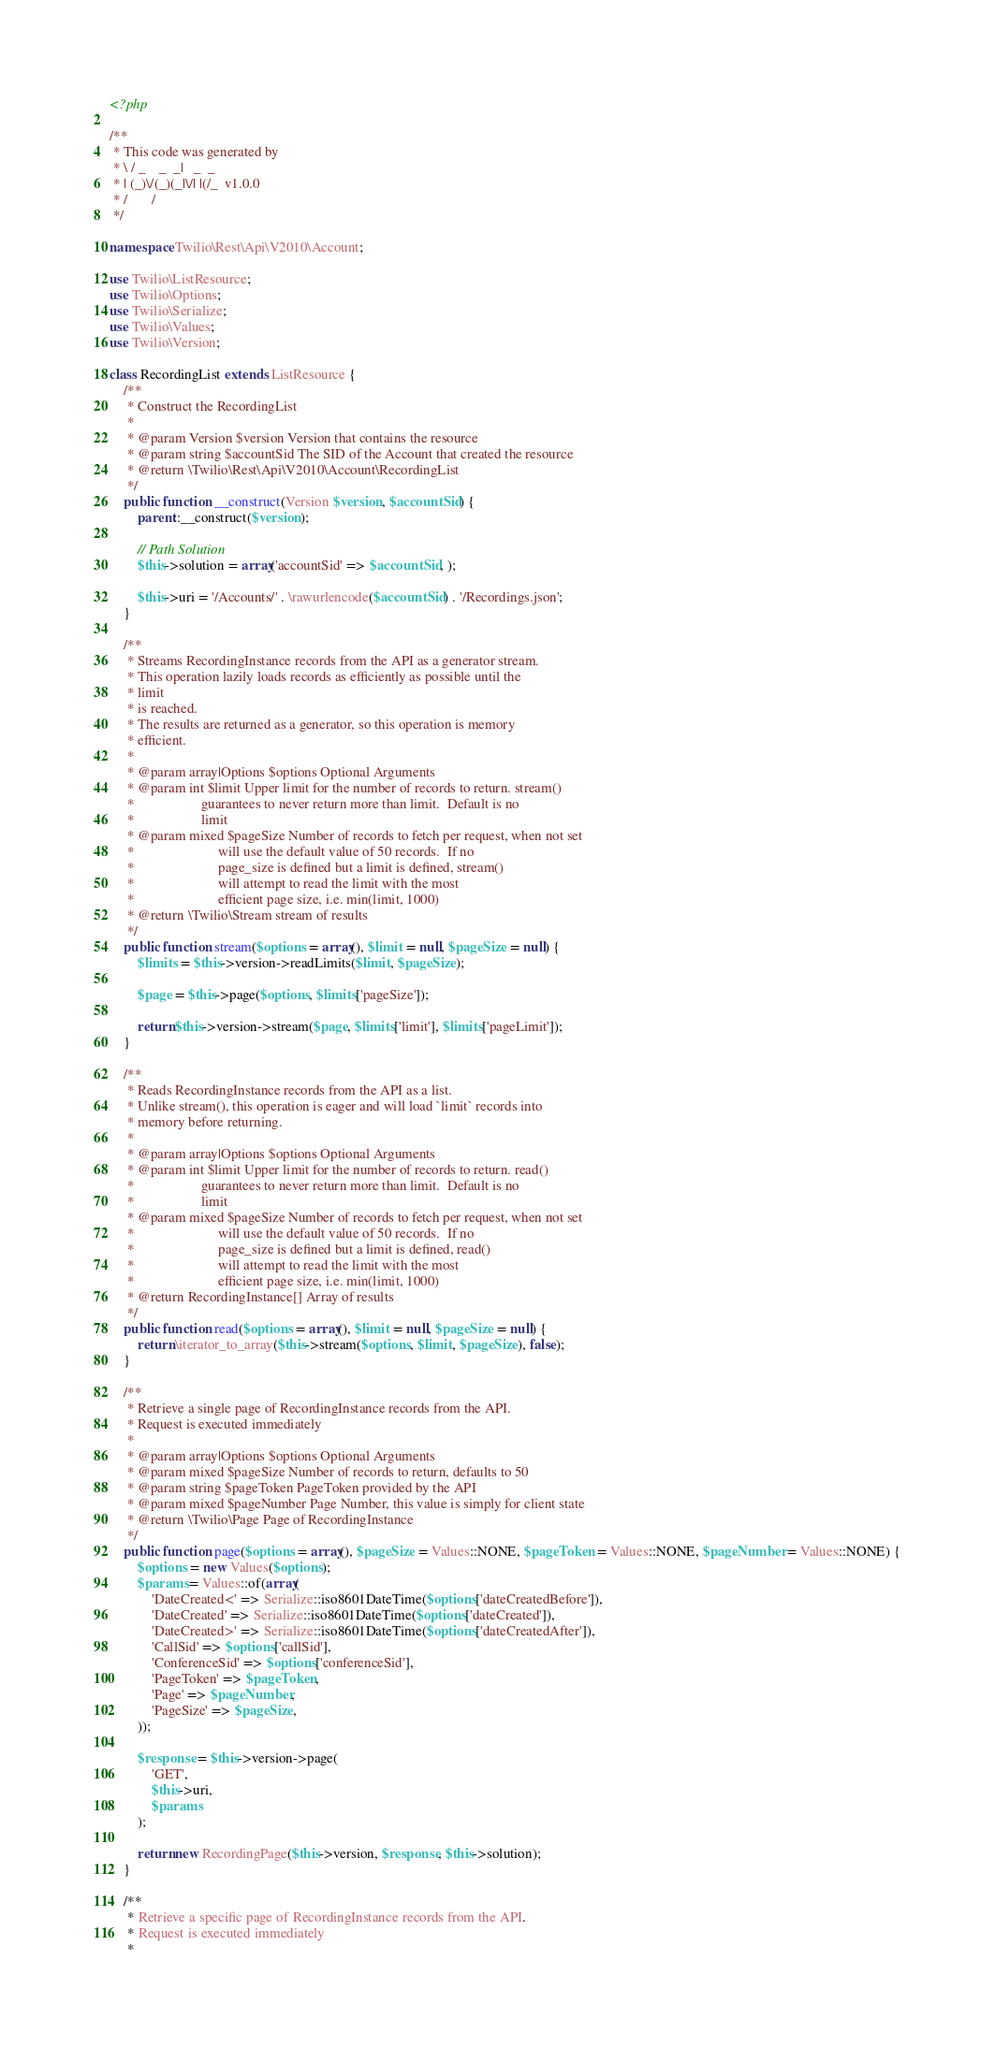<code> <loc_0><loc_0><loc_500><loc_500><_PHP_><?php

/**
 * This code was generated by
 * \ / _    _  _|   _  _
 * | (_)\/(_)(_|\/| |(/_  v1.0.0
 * /       /
 */

namespace Twilio\Rest\Api\V2010\Account;

use Twilio\ListResource;
use Twilio\Options;
use Twilio\Serialize;
use Twilio\Values;
use Twilio\Version;

class RecordingList extends ListResource {
    /**
     * Construct the RecordingList
     *
     * @param Version $version Version that contains the resource
     * @param string $accountSid The SID of the Account that created the resource
     * @return \Twilio\Rest\Api\V2010\Account\RecordingList
     */
    public function __construct(Version $version, $accountSid) {
        parent::__construct($version);

        // Path Solution
        $this->solution = array('accountSid' => $accountSid, );

        $this->uri = '/Accounts/' . \rawurlencode($accountSid) . '/Recordings.json';
    }

    /**
     * Streams RecordingInstance records from the API as a generator stream.
     * This operation lazily loads records as efficiently as possible until the
     * limit
     * is reached.
     * The results are returned as a generator, so this operation is memory
     * efficient.
     *
     * @param array|Options $options Optional Arguments
     * @param int $limit Upper limit for the number of records to return. stream()
     *                   guarantees to never return more than limit.  Default is no
     *                   limit
     * @param mixed $pageSize Number of records to fetch per request, when not set
     *                        will use the default value of 50 records.  If no
     *                        page_size is defined but a limit is defined, stream()
     *                        will attempt to read the limit with the most
     *                        efficient page size, i.e. min(limit, 1000)
     * @return \Twilio\Stream stream of results
     */
    public function stream($options = array(), $limit = null, $pageSize = null) {
        $limits = $this->version->readLimits($limit, $pageSize);

        $page = $this->page($options, $limits['pageSize']);

        return $this->version->stream($page, $limits['limit'], $limits['pageLimit']);
    }

    /**
     * Reads RecordingInstance records from the API as a list.
     * Unlike stream(), this operation is eager and will load `limit` records into
     * memory before returning.
     *
     * @param array|Options $options Optional Arguments
     * @param int $limit Upper limit for the number of records to return. read()
     *                   guarantees to never return more than limit.  Default is no
     *                   limit
     * @param mixed $pageSize Number of records to fetch per request, when not set
     *                        will use the default value of 50 records.  If no
     *                        page_size is defined but a limit is defined, read()
     *                        will attempt to read the limit with the most
     *                        efficient page size, i.e. min(limit, 1000)
     * @return RecordingInstance[] Array of results
     */
    public function read($options = array(), $limit = null, $pageSize = null) {
        return \iterator_to_array($this->stream($options, $limit, $pageSize), false);
    }

    /**
     * Retrieve a single page of RecordingInstance records from the API.
     * Request is executed immediately
     *
     * @param array|Options $options Optional Arguments
     * @param mixed $pageSize Number of records to return, defaults to 50
     * @param string $pageToken PageToken provided by the API
     * @param mixed $pageNumber Page Number, this value is simply for client state
     * @return \Twilio\Page Page of RecordingInstance
     */
    public function page($options = array(), $pageSize = Values::NONE, $pageToken = Values::NONE, $pageNumber = Values::NONE) {
        $options = new Values($options);
        $params = Values::of(array(
            'DateCreated<' => Serialize::iso8601DateTime($options['dateCreatedBefore']),
            'DateCreated' => Serialize::iso8601DateTime($options['dateCreated']),
            'DateCreated>' => Serialize::iso8601DateTime($options['dateCreatedAfter']),
            'CallSid' => $options['callSid'],
            'ConferenceSid' => $options['conferenceSid'],
            'PageToken' => $pageToken,
            'Page' => $pageNumber,
            'PageSize' => $pageSize,
        ));

        $response = $this->version->page(
            'GET',
            $this->uri,
            $params
        );

        return new RecordingPage($this->version, $response, $this->solution);
    }

    /**
     * Retrieve a specific page of RecordingInstance records from the API.
     * Request is executed immediately
     *</code> 